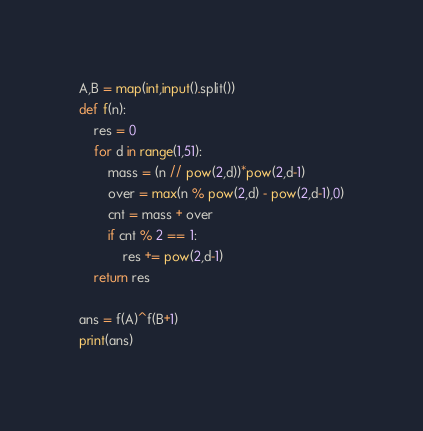<code> <loc_0><loc_0><loc_500><loc_500><_Python_>A,B = map(int,input().split())
def f(n):
    res = 0
    for d in range(1,51):
        mass = (n // pow(2,d))*pow(2,d-1)
        over = max(n % pow(2,d) - pow(2,d-1),0)
        cnt = mass + over
        if cnt % 2 == 1:
            res += pow(2,d-1)
    return res

ans = f(A)^f(B+1)
print(ans)</code> 